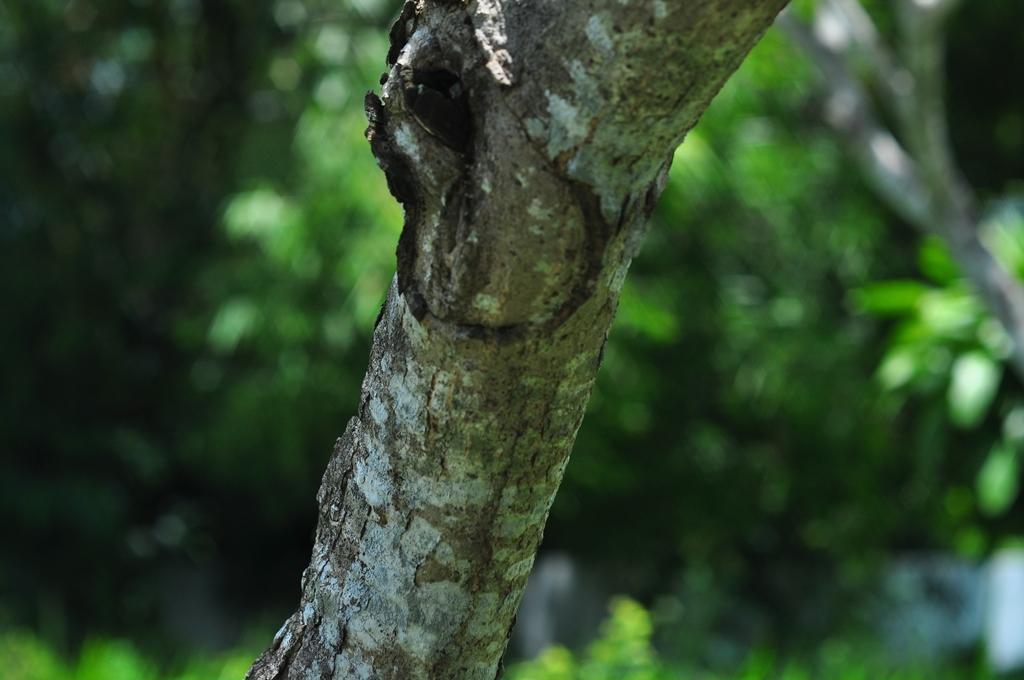Can you describe this image briefly? In this image we can see a branch of a tree. In the background, we can see a group of trees. 